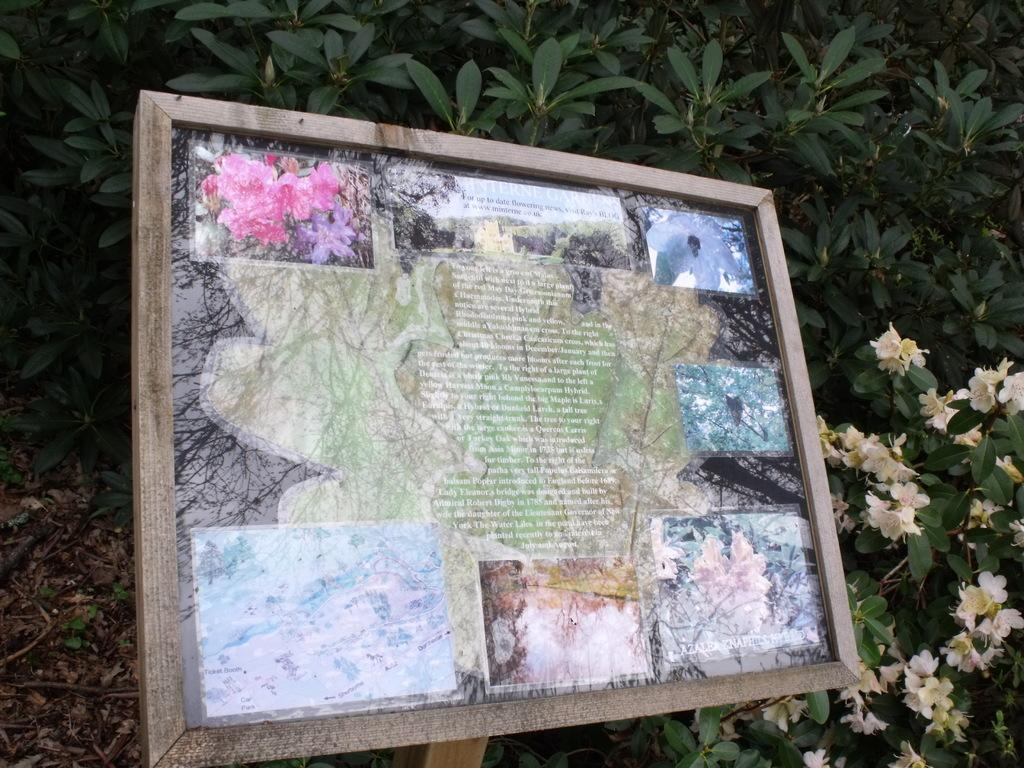What is located in the foreground of the image? There is a frame in the foreground of the image. What is inside the frame? There are photos inside the frame. What can be seen in the background of the image? There are flowers and plants in the background of the image. Can you tell me how many receipts are visible in the image? There are no receipts visible in the image. What type of straw is used to decorate the flowers in the image? There is no straw present in the image; it features a frame with photos and flowers in the background. 